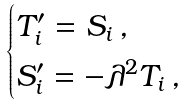Convert formula to latex. <formula><loc_0><loc_0><loc_500><loc_500>\begin{cases} T ^ { \prime } _ { i } = S _ { i } \, , \\ S ^ { \prime } _ { i } = - \lambda ^ { 2 } T _ { i } \, , \end{cases}</formula> 